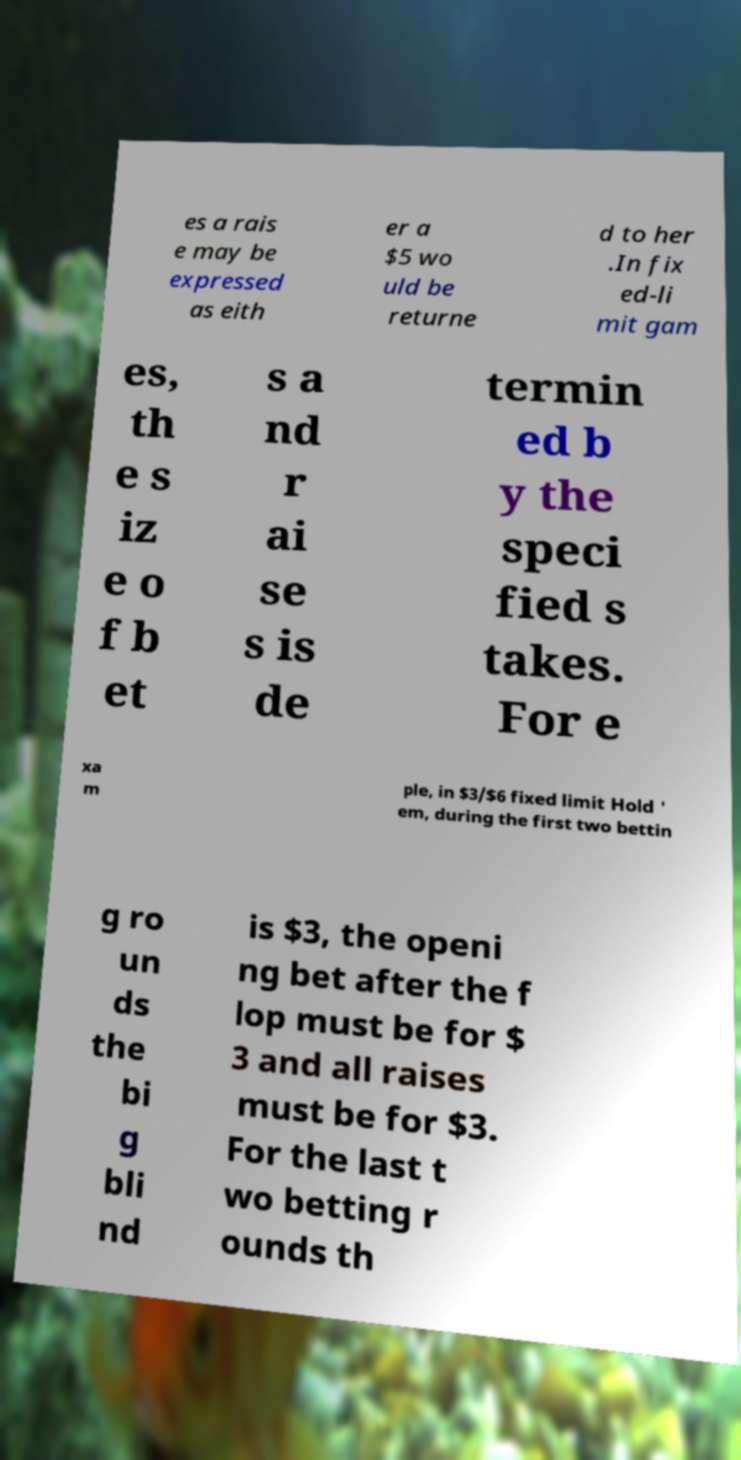There's text embedded in this image that I need extracted. Can you transcribe it verbatim? es a rais e may be expressed as eith er a $5 wo uld be returne d to her .In fix ed-li mit gam es, th e s iz e o f b et s a nd r ai se s is de termin ed b y the speci fied s takes. For e xa m ple, in $3/$6 fixed limit Hold ' em, during the first two bettin g ro un ds the bi g bli nd is $3, the openi ng bet after the f lop must be for $ 3 and all raises must be for $3. For the last t wo betting r ounds th 